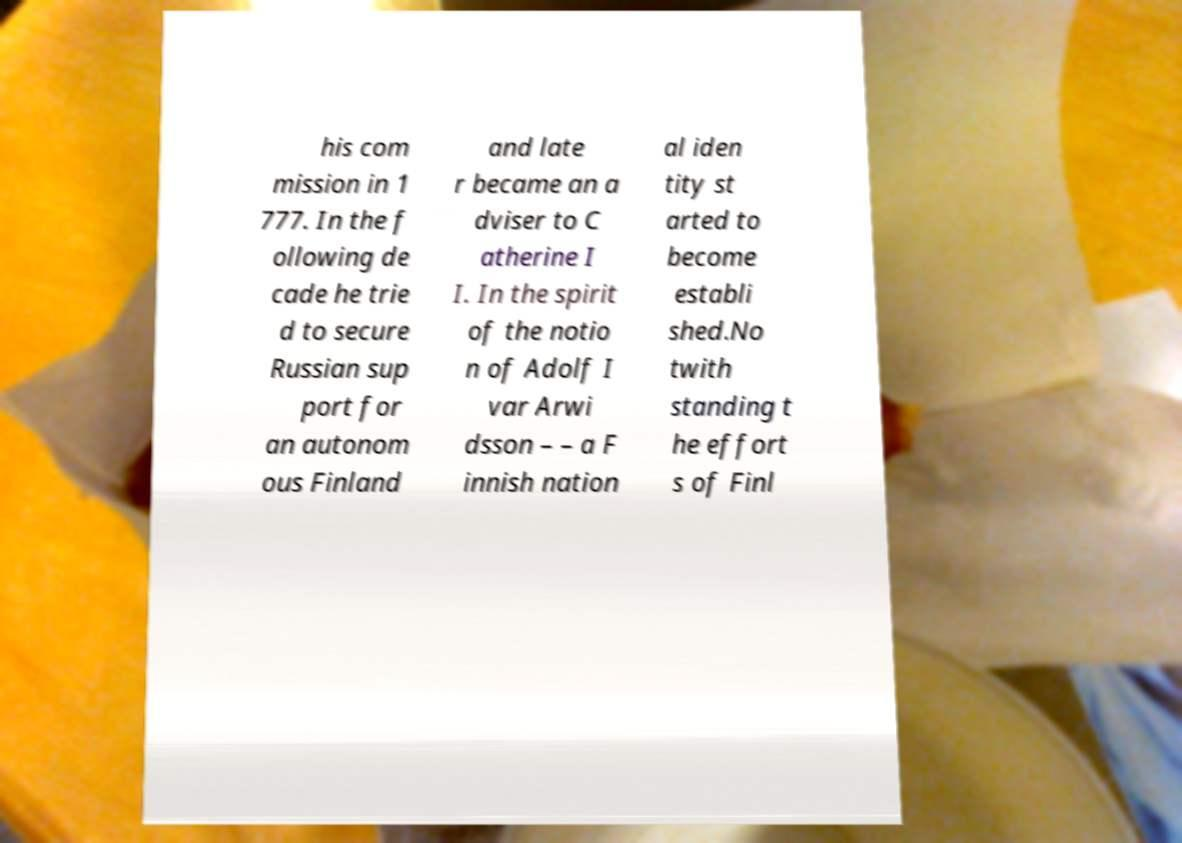I need the written content from this picture converted into text. Can you do that? his com mission in 1 777. In the f ollowing de cade he trie d to secure Russian sup port for an autonom ous Finland and late r became an a dviser to C atherine I I. In the spirit of the notio n of Adolf I var Arwi dsson – – a F innish nation al iden tity st arted to become establi shed.No twith standing t he effort s of Finl 